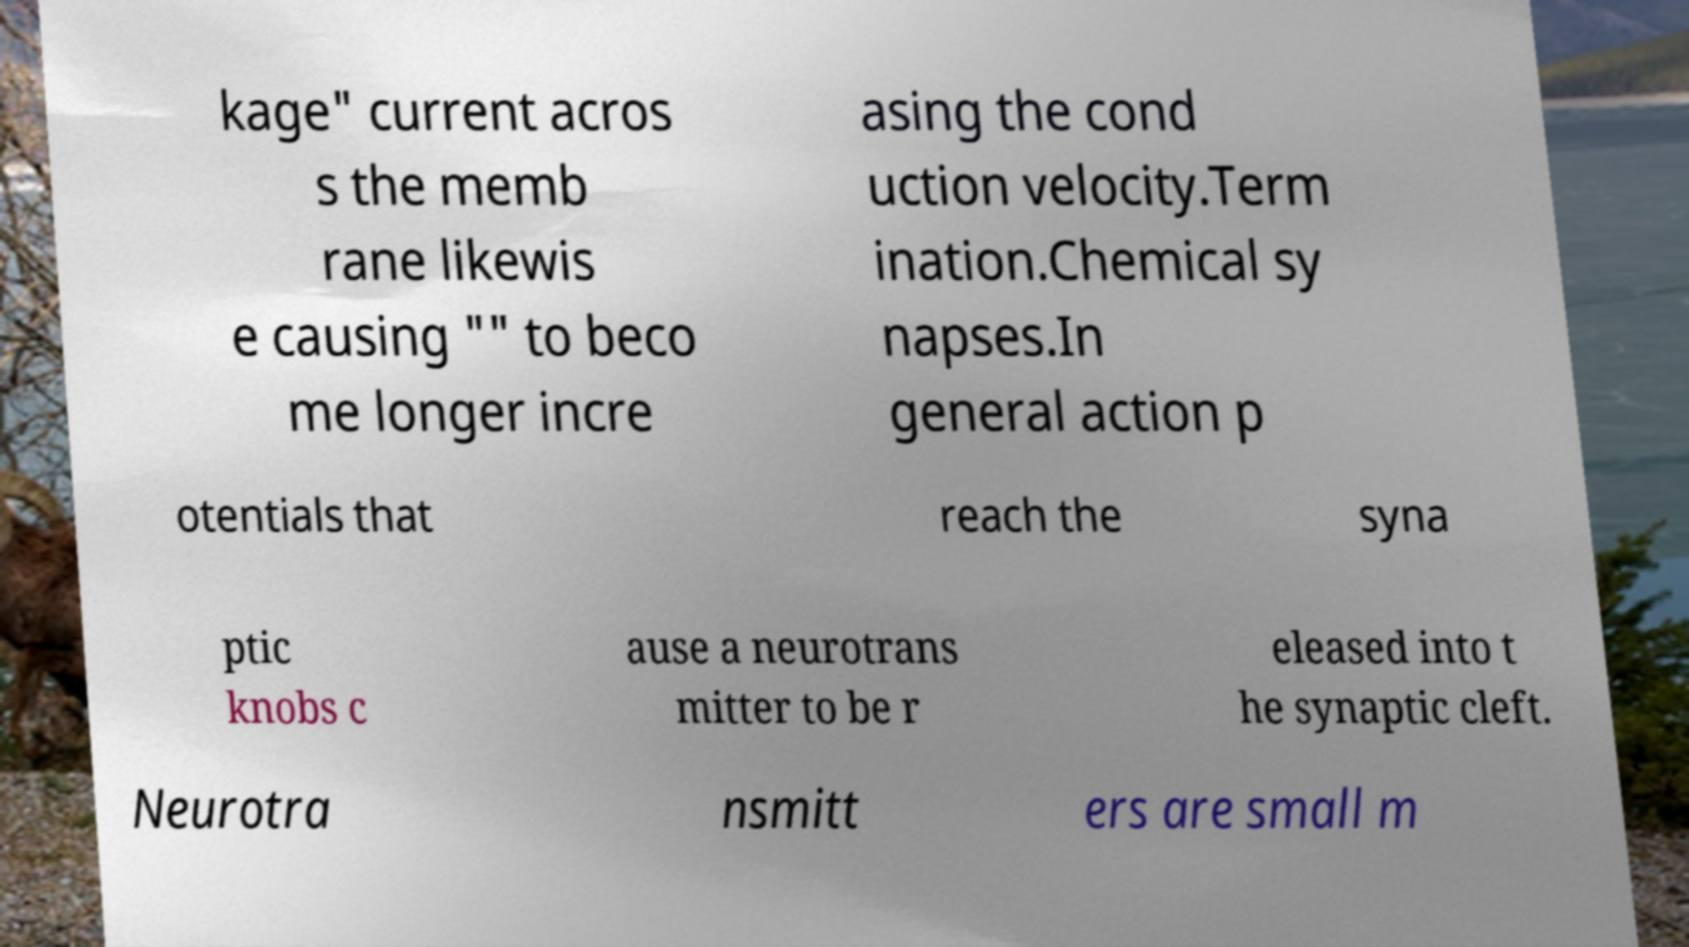Please identify and transcribe the text found in this image. kage" current acros s the memb rane likewis e causing "" to beco me longer incre asing the cond uction velocity.Term ination.Chemical sy napses.In general action p otentials that reach the syna ptic knobs c ause a neurotrans mitter to be r eleased into t he synaptic cleft. Neurotra nsmitt ers are small m 